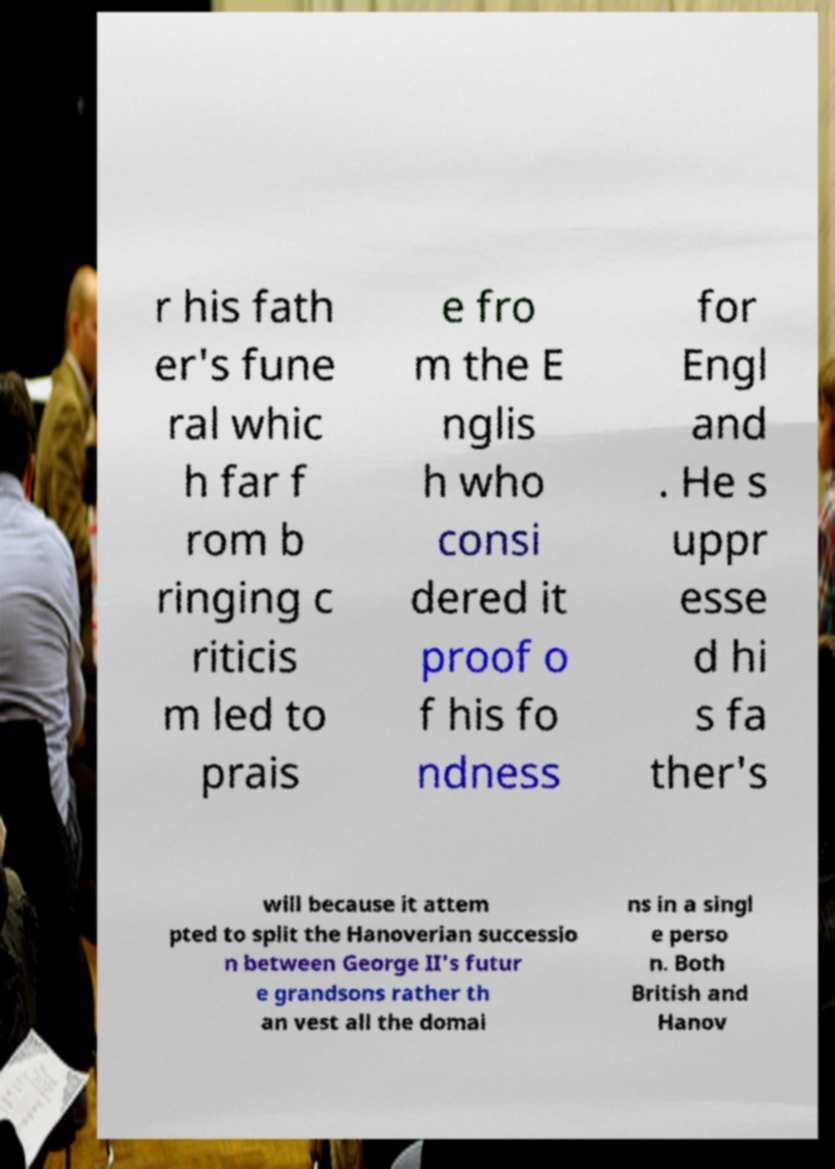I need the written content from this picture converted into text. Can you do that? r his fath er's fune ral whic h far f rom b ringing c riticis m led to prais e fro m the E nglis h who consi dered it proof o f his fo ndness for Engl and . He s uppr esse d hi s fa ther's will because it attem pted to split the Hanoverian successio n between George II's futur e grandsons rather th an vest all the domai ns in a singl e perso n. Both British and Hanov 